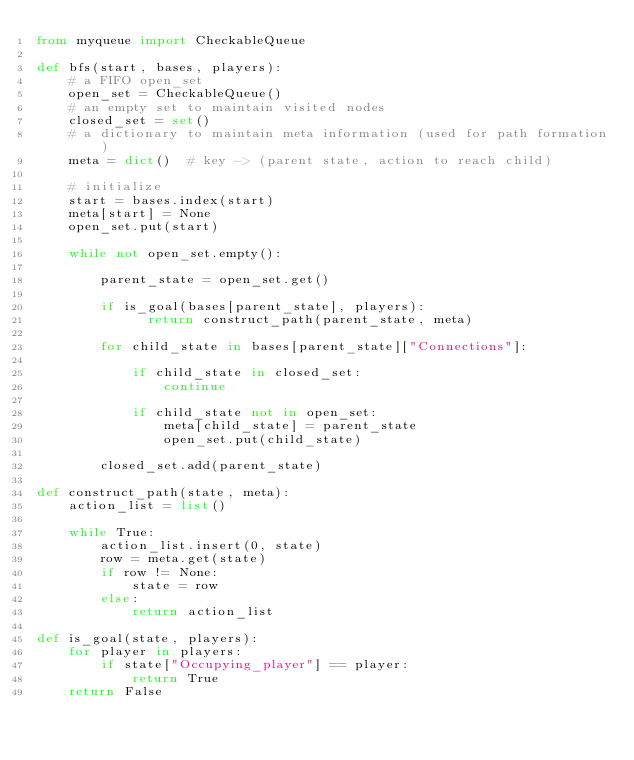Convert code to text. <code><loc_0><loc_0><loc_500><loc_500><_Python_>from myqueue import CheckableQueue

def bfs(start, bases, players):
    # a FIFO open_set
    open_set = CheckableQueue()
    # an empty set to maintain visited nodes
    closed_set = set()
    # a dictionary to maintain meta information (used for path formation)
    meta = dict()  # key -> (parent state, action to reach child)

    # initialize
    start = bases.index(start)
    meta[start] = None
    open_set.put(start)

    while not open_set.empty():

        parent_state = open_set.get()

        if is_goal(bases[parent_state], players):
              return construct_path(parent_state, meta)

        for child_state in bases[parent_state]["Connections"]:

            if child_state in closed_set:
                continue

            if child_state not in open_set:
                meta[child_state] = parent_state
                open_set.put(child_state)

        closed_set.add(parent_state)

def construct_path(state, meta):
    action_list = list()

    while True:
        action_list.insert(0, state)
        row = meta.get(state)
        if row != None:
            state = row
        else:
            return action_list

def is_goal(state, players):
    for player in players:
        if state["Occupying_player"] == player:
            return True
    return False
</code> 